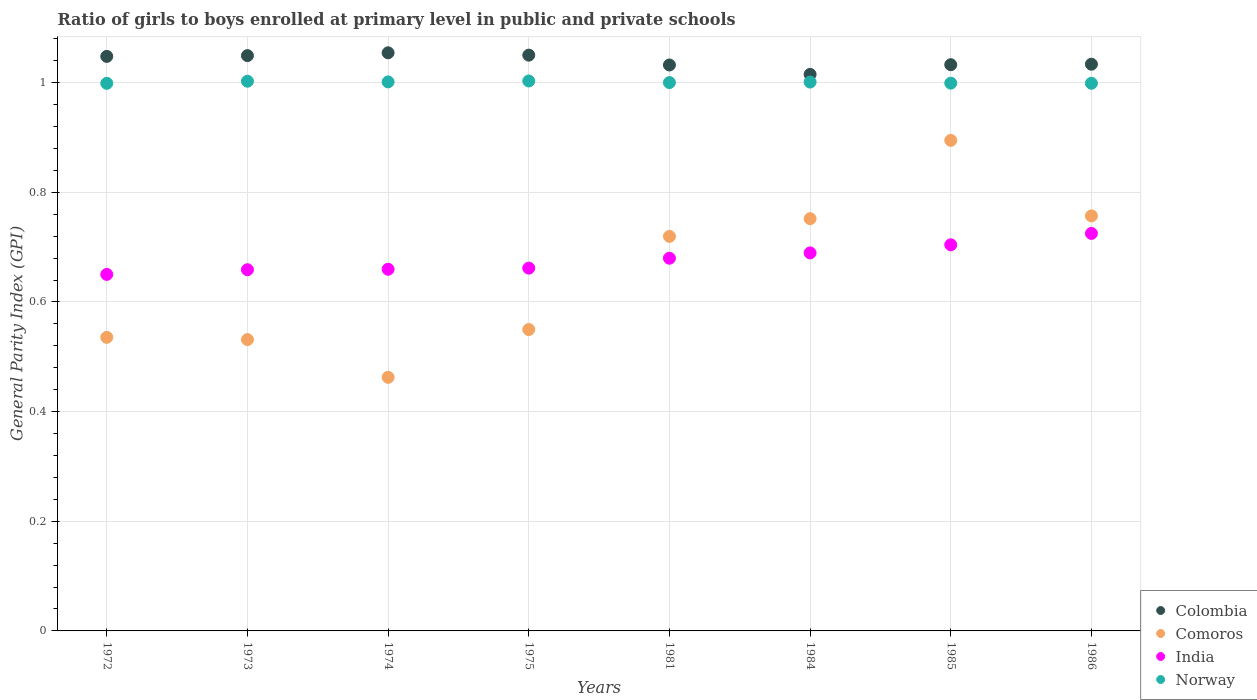How many different coloured dotlines are there?
Keep it short and to the point. 4. Is the number of dotlines equal to the number of legend labels?
Offer a very short reply. Yes. What is the general parity index in Comoros in 1975?
Your answer should be very brief. 0.55. Across all years, what is the maximum general parity index in Colombia?
Your answer should be very brief. 1.05. Across all years, what is the minimum general parity index in Colombia?
Offer a very short reply. 1.02. In which year was the general parity index in Norway maximum?
Keep it short and to the point. 1975. What is the total general parity index in Colombia in the graph?
Give a very brief answer. 8.32. What is the difference between the general parity index in Norway in 1973 and that in 1974?
Make the answer very short. 0. What is the difference between the general parity index in Norway in 1973 and the general parity index in India in 1974?
Offer a very short reply. 0.34. What is the average general parity index in India per year?
Keep it short and to the point. 0.68. In the year 1974, what is the difference between the general parity index in Colombia and general parity index in India?
Make the answer very short. 0.39. In how many years, is the general parity index in Colombia greater than 0.6400000000000001?
Make the answer very short. 8. What is the ratio of the general parity index in India in 1972 to that in 1973?
Give a very brief answer. 0.99. Is the general parity index in Colombia in 1974 less than that in 1984?
Keep it short and to the point. No. What is the difference between the highest and the second highest general parity index in Comoros?
Ensure brevity in your answer.  0.14. What is the difference between the highest and the lowest general parity index in India?
Give a very brief answer. 0.07. Is it the case that in every year, the sum of the general parity index in Comoros and general parity index in Norway  is greater than the sum of general parity index in India and general parity index in Colombia?
Make the answer very short. Yes. Is it the case that in every year, the sum of the general parity index in India and general parity index in Comoros  is greater than the general parity index in Colombia?
Your answer should be very brief. Yes. Is the general parity index in Norway strictly greater than the general parity index in Colombia over the years?
Keep it short and to the point. No. How many dotlines are there?
Your answer should be compact. 4. Does the graph contain any zero values?
Make the answer very short. No. Does the graph contain grids?
Offer a terse response. Yes. What is the title of the graph?
Offer a very short reply. Ratio of girls to boys enrolled at primary level in public and private schools. Does "Panama" appear as one of the legend labels in the graph?
Keep it short and to the point. No. What is the label or title of the X-axis?
Provide a succinct answer. Years. What is the label or title of the Y-axis?
Offer a terse response. General Parity Index (GPI). What is the General Parity Index (GPI) in Colombia in 1972?
Keep it short and to the point. 1.05. What is the General Parity Index (GPI) in Comoros in 1972?
Provide a short and direct response. 0.54. What is the General Parity Index (GPI) of India in 1972?
Your response must be concise. 0.65. What is the General Parity Index (GPI) of Norway in 1972?
Provide a short and direct response. 1. What is the General Parity Index (GPI) in Colombia in 1973?
Ensure brevity in your answer.  1.05. What is the General Parity Index (GPI) of Comoros in 1973?
Give a very brief answer. 0.53. What is the General Parity Index (GPI) in India in 1973?
Ensure brevity in your answer.  0.66. What is the General Parity Index (GPI) in Norway in 1973?
Offer a very short reply. 1. What is the General Parity Index (GPI) in Colombia in 1974?
Your answer should be compact. 1.05. What is the General Parity Index (GPI) of Comoros in 1974?
Your answer should be compact. 0.46. What is the General Parity Index (GPI) of India in 1974?
Offer a terse response. 0.66. What is the General Parity Index (GPI) of Norway in 1974?
Your answer should be compact. 1. What is the General Parity Index (GPI) of Colombia in 1975?
Ensure brevity in your answer.  1.05. What is the General Parity Index (GPI) in Comoros in 1975?
Your response must be concise. 0.55. What is the General Parity Index (GPI) in India in 1975?
Offer a very short reply. 0.66. What is the General Parity Index (GPI) in Norway in 1975?
Your answer should be very brief. 1. What is the General Parity Index (GPI) of Colombia in 1981?
Give a very brief answer. 1.03. What is the General Parity Index (GPI) in Comoros in 1981?
Provide a short and direct response. 0.72. What is the General Parity Index (GPI) of India in 1981?
Provide a short and direct response. 0.68. What is the General Parity Index (GPI) in Norway in 1981?
Offer a terse response. 1. What is the General Parity Index (GPI) in Colombia in 1984?
Your response must be concise. 1.02. What is the General Parity Index (GPI) of Comoros in 1984?
Your answer should be very brief. 0.75. What is the General Parity Index (GPI) of India in 1984?
Keep it short and to the point. 0.69. What is the General Parity Index (GPI) in Norway in 1984?
Your response must be concise. 1. What is the General Parity Index (GPI) of Colombia in 1985?
Keep it short and to the point. 1.03. What is the General Parity Index (GPI) of Comoros in 1985?
Keep it short and to the point. 0.89. What is the General Parity Index (GPI) in India in 1985?
Keep it short and to the point. 0.7. What is the General Parity Index (GPI) of Norway in 1985?
Your response must be concise. 1. What is the General Parity Index (GPI) of Colombia in 1986?
Your answer should be very brief. 1.03. What is the General Parity Index (GPI) in Comoros in 1986?
Your answer should be very brief. 0.76. What is the General Parity Index (GPI) of India in 1986?
Give a very brief answer. 0.73. What is the General Parity Index (GPI) in Norway in 1986?
Your answer should be compact. 1. Across all years, what is the maximum General Parity Index (GPI) of Colombia?
Make the answer very short. 1.05. Across all years, what is the maximum General Parity Index (GPI) of Comoros?
Give a very brief answer. 0.89. Across all years, what is the maximum General Parity Index (GPI) of India?
Keep it short and to the point. 0.73. Across all years, what is the maximum General Parity Index (GPI) in Norway?
Ensure brevity in your answer.  1. Across all years, what is the minimum General Parity Index (GPI) in Colombia?
Give a very brief answer. 1.02. Across all years, what is the minimum General Parity Index (GPI) in Comoros?
Offer a terse response. 0.46. Across all years, what is the minimum General Parity Index (GPI) in India?
Ensure brevity in your answer.  0.65. Across all years, what is the minimum General Parity Index (GPI) of Norway?
Provide a succinct answer. 1. What is the total General Parity Index (GPI) of Colombia in the graph?
Provide a succinct answer. 8.32. What is the total General Parity Index (GPI) of Comoros in the graph?
Give a very brief answer. 5.2. What is the total General Parity Index (GPI) of India in the graph?
Offer a very short reply. 5.43. What is the total General Parity Index (GPI) in Norway in the graph?
Ensure brevity in your answer.  8.01. What is the difference between the General Parity Index (GPI) in Colombia in 1972 and that in 1973?
Provide a succinct answer. -0. What is the difference between the General Parity Index (GPI) of Comoros in 1972 and that in 1973?
Ensure brevity in your answer.  0. What is the difference between the General Parity Index (GPI) of India in 1972 and that in 1973?
Your answer should be very brief. -0.01. What is the difference between the General Parity Index (GPI) in Norway in 1972 and that in 1973?
Your response must be concise. -0. What is the difference between the General Parity Index (GPI) of Colombia in 1972 and that in 1974?
Ensure brevity in your answer.  -0.01. What is the difference between the General Parity Index (GPI) of Comoros in 1972 and that in 1974?
Your answer should be compact. 0.07. What is the difference between the General Parity Index (GPI) in India in 1972 and that in 1974?
Your response must be concise. -0.01. What is the difference between the General Parity Index (GPI) in Norway in 1972 and that in 1974?
Your response must be concise. -0. What is the difference between the General Parity Index (GPI) of Colombia in 1972 and that in 1975?
Provide a short and direct response. -0. What is the difference between the General Parity Index (GPI) of Comoros in 1972 and that in 1975?
Make the answer very short. -0.01. What is the difference between the General Parity Index (GPI) in India in 1972 and that in 1975?
Ensure brevity in your answer.  -0.01. What is the difference between the General Parity Index (GPI) of Norway in 1972 and that in 1975?
Your response must be concise. -0. What is the difference between the General Parity Index (GPI) of Colombia in 1972 and that in 1981?
Provide a succinct answer. 0.02. What is the difference between the General Parity Index (GPI) in Comoros in 1972 and that in 1981?
Ensure brevity in your answer.  -0.18. What is the difference between the General Parity Index (GPI) of India in 1972 and that in 1981?
Provide a short and direct response. -0.03. What is the difference between the General Parity Index (GPI) in Norway in 1972 and that in 1981?
Provide a short and direct response. -0. What is the difference between the General Parity Index (GPI) of Colombia in 1972 and that in 1984?
Provide a short and direct response. 0.03. What is the difference between the General Parity Index (GPI) in Comoros in 1972 and that in 1984?
Give a very brief answer. -0.22. What is the difference between the General Parity Index (GPI) in India in 1972 and that in 1984?
Give a very brief answer. -0.04. What is the difference between the General Parity Index (GPI) of Norway in 1972 and that in 1984?
Provide a short and direct response. -0. What is the difference between the General Parity Index (GPI) in Colombia in 1972 and that in 1985?
Offer a very short reply. 0.02. What is the difference between the General Parity Index (GPI) in Comoros in 1972 and that in 1985?
Offer a very short reply. -0.36. What is the difference between the General Parity Index (GPI) in India in 1972 and that in 1985?
Make the answer very short. -0.05. What is the difference between the General Parity Index (GPI) in Norway in 1972 and that in 1985?
Give a very brief answer. -0. What is the difference between the General Parity Index (GPI) of Colombia in 1972 and that in 1986?
Your response must be concise. 0.01. What is the difference between the General Parity Index (GPI) in Comoros in 1972 and that in 1986?
Keep it short and to the point. -0.22. What is the difference between the General Parity Index (GPI) of India in 1972 and that in 1986?
Your answer should be very brief. -0.07. What is the difference between the General Parity Index (GPI) of Norway in 1972 and that in 1986?
Ensure brevity in your answer.  -0. What is the difference between the General Parity Index (GPI) of Colombia in 1973 and that in 1974?
Give a very brief answer. -0.01. What is the difference between the General Parity Index (GPI) of Comoros in 1973 and that in 1974?
Provide a short and direct response. 0.07. What is the difference between the General Parity Index (GPI) in India in 1973 and that in 1974?
Provide a short and direct response. -0. What is the difference between the General Parity Index (GPI) of Norway in 1973 and that in 1974?
Offer a very short reply. 0. What is the difference between the General Parity Index (GPI) of Colombia in 1973 and that in 1975?
Provide a succinct answer. -0. What is the difference between the General Parity Index (GPI) of Comoros in 1973 and that in 1975?
Ensure brevity in your answer.  -0.02. What is the difference between the General Parity Index (GPI) of India in 1973 and that in 1975?
Your answer should be very brief. -0. What is the difference between the General Parity Index (GPI) of Norway in 1973 and that in 1975?
Give a very brief answer. -0. What is the difference between the General Parity Index (GPI) of Colombia in 1973 and that in 1981?
Your response must be concise. 0.02. What is the difference between the General Parity Index (GPI) in Comoros in 1973 and that in 1981?
Provide a succinct answer. -0.19. What is the difference between the General Parity Index (GPI) of India in 1973 and that in 1981?
Provide a succinct answer. -0.02. What is the difference between the General Parity Index (GPI) of Norway in 1973 and that in 1981?
Provide a short and direct response. 0. What is the difference between the General Parity Index (GPI) of Colombia in 1973 and that in 1984?
Provide a short and direct response. 0.03. What is the difference between the General Parity Index (GPI) in Comoros in 1973 and that in 1984?
Offer a very short reply. -0.22. What is the difference between the General Parity Index (GPI) of India in 1973 and that in 1984?
Offer a terse response. -0.03. What is the difference between the General Parity Index (GPI) of Norway in 1973 and that in 1984?
Your answer should be very brief. 0. What is the difference between the General Parity Index (GPI) of Colombia in 1973 and that in 1985?
Provide a succinct answer. 0.02. What is the difference between the General Parity Index (GPI) of Comoros in 1973 and that in 1985?
Give a very brief answer. -0.36. What is the difference between the General Parity Index (GPI) of India in 1973 and that in 1985?
Offer a terse response. -0.05. What is the difference between the General Parity Index (GPI) in Norway in 1973 and that in 1985?
Make the answer very short. 0. What is the difference between the General Parity Index (GPI) in Colombia in 1973 and that in 1986?
Offer a terse response. 0.02. What is the difference between the General Parity Index (GPI) of Comoros in 1973 and that in 1986?
Provide a succinct answer. -0.23. What is the difference between the General Parity Index (GPI) of India in 1973 and that in 1986?
Make the answer very short. -0.07. What is the difference between the General Parity Index (GPI) in Norway in 1973 and that in 1986?
Ensure brevity in your answer.  0. What is the difference between the General Parity Index (GPI) in Colombia in 1974 and that in 1975?
Ensure brevity in your answer.  0. What is the difference between the General Parity Index (GPI) in Comoros in 1974 and that in 1975?
Provide a succinct answer. -0.09. What is the difference between the General Parity Index (GPI) in India in 1974 and that in 1975?
Offer a terse response. -0. What is the difference between the General Parity Index (GPI) of Norway in 1974 and that in 1975?
Offer a very short reply. -0. What is the difference between the General Parity Index (GPI) of Colombia in 1974 and that in 1981?
Your answer should be compact. 0.02. What is the difference between the General Parity Index (GPI) of Comoros in 1974 and that in 1981?
Offer a very short reply. -0.26. What is the difference between the General Parity Index (GPI) of India in 1974 and that in 1981?
Provide a short and direct response. -0.02. What is the difference between the General Parity Index (GPI) of Norway in 1974 and that in 1981?
Provide a succinct answer. 0. What is the difference between the General Parity Index (GPI) in Colombia in 1974 and that in 1984?
Keep it short and to the point. 0.04. What is the difference between the General Parity Index (GPI) in Comoros in 1974 and that in 1984?
Keep it short and to the point. -0.29. What is the difference between the General Parity Index (GPI) in India in 1974 and that in 1984?
Provide a short and direct response. -0.03. What is the difference between the General Parity Index (GPI) of Norway in 1974 and that in 1984?
Give a very brief answer. 0. What is the difference between the General Parity Index (GPI) in Colombia in 1974 and that in 1985?
Provide a short and direct response. 0.02. What is the difference between the General Parity Index (GPI) in Comoros in 1974 and that in 1985?
Provide a succinct answer. -0.43. What is the difference between the General Parity Index (GPI) of India in 1974 and that in 1985?
Ensure brevity in your answer.  -0.04. What is the difference between the General Parity Index (GPI) of Norway in 1974 and that in 1985?
Give a very brief answer. 0. What is the difference between the General Parity Index (GPI) of Colombia in 1974 and that in 1986?
Provide a short and direct response. 0.02. What is the difference between the General Parity Index (GPI) in Comoros in 1974 and that in 1986?
Offer a very short reply. -0.29. What is the difference between the General Parity Index (GPI) in India in 1974 and that in 1986?
Your response must be concise. -0.07. What is the difference between the General Parity Index (GPI) of Norway in 1974 and that in 1986?
Your answer should be compact. 0. What is the difference between the General Parity Index (GPI) of Colombia in 1975 and that in 1981?
Your response must be concise. 0.02. What is the difference between the General Parity Index (GPI) in Comoros in 1975 and that in 1981?
Your answer should be compact. -0.17. What is the difference between the General Parity Index (GPI) of India in 1975 and that in 1981?
Offer a terse response. -0.02. What is the difference between the General Parity Index (GPI) in Norway in 1975 and that in 1981?
Offer a very short reply. 0. What is the difference between the General Parity Index (GPI) of Colombia in 1975 and that in 1984?
Offer a terse response. 0.04. What is the difference between the General Parity Index (GPI) of Comoros in 1975 and that in 1984?
Make the answer very short. -0.2. What is the difference between the General Parity Index (GPI) in India in 1975 and that in 1984?
Ensure brevity in your answer.  -0.03. What is the difference between the General Parity Index (GPI) of Norway in 1975 and that in 1984?
Offer a terse response. 0. What is the difference between the General Parity Index (GPI) in Colombia in 1975 and that in 1985?
Provide a short and direct response. 0.02. What is the difference between the General Parity Index (GPI) in Comoros in 1975 and that in 1985?
Ensure brevity in your answer.  -0.34. What is the difference between the General Parity Index (GPI) of India in 1975 and that in 1985?
Keep it short and to the point. -0.04. What is the difference between the General Parity Index (GPI) of Norway in 1975 and that in 1985?
Provide a short and direct response. 0. What is the difference between the General Parity Index (GPI) in Colombia in 1975 and that in 1986?
Offer a very short reply. 0.02. What is the difference between the General Parity Index (GPI) of Comoros in 1975 and that in 1986?
Your answer should be very brief. -0.21. What is the difference between the General Parity Index (GPI) in India in 1975 and that in 1986?
Offer a terse response. -0.06. What is the difference between the General Parity Index (GPI) in Norway in 1975 and that in 1986?
Offer a very short reply. 0. What is the difference between the General Parity Index (GPI) in Colombia in 1981 and that in 1984?
Offer a terse response. 0.02. What is the difference between the General Parity Index (GPI) of Comoros in 1981 and that in 1984?
Provide a short and direct response. -0.03. What is the difference between the General Parity Index (GPI) in India in 1981 and that in 1984?
Give a very brief answer. -0.01. What is the difference between the General Parity Index (GPI) in Norway in 1981 and that in 1984?
Provide a short and direct response. -0. What is the difference between the General Parity Index (GPI) of Colombia in 1981 and that in 1985?
Keep it short and to the point. -0. What is the difference between the General Parity Index (GPI) in Comoros in 1981 and that in 1985?
Your response must be concise. -0.18. What is the difference between the General Parity Index (GPI) of India in 1981 and that in 1985?
Your answer should be compact. -0.02. What is the difference between the General Parity Index (GPI) of Norway in 1981 and that in 1985?
Give a very brief answer. 0. What is the difference between the General Parity Index (GPI) of Colombia in 1981 and that in 1986?
Your answer should be very brief. -0. What is the difference between the General Parity Index (GPI) in Comoros in 1981 and that in 1986?
Offer a terse response. -0.04. What is the difference between the General Parity Index (GPI) of India in 1981 and that in 1986?
Provide a succinct answer. -0.05. What is the difference between the General Parity Index (GPI) in Norway in 1981 and that in 1986?
Offer a very short reply. 0. What is the difference between the General Parity Index (GPI) in Colombia in 1984 and that in 1985?
Ensure brevity in your answer.  -0.02. What is the difference between the General Parity Index (GPI) in Comoros in 1984 and that in 1985?
Offer a very short reply. -0.14. What is the difference between the General Parity Index (GPI) of India in 1984 and that in 1985?
Your answer should be very brief. -0.01. What is the difference between the General Parity Index (GPI) of Norway in 1984 and that in 1985?
Provide a succinct answer. 0. What is the difference between the General Parity Index (GPI) in Colombia in 1984 and that in 1986?
Provide a succinct answer. -0.02. What is the difference between the General Parity Index (GPI) of Comoros in 1984 and that in 1986?
Provide a short and direct response. -0.01. What is the difference between the General Parity Index (GPI) of India in 1984 and that in 1986?
Your answer should be compact. -0.04. What is the difference between the General Parity Index (GPI) in Norway in 1984 and that in 1986?
Your response must be concise. 0. What is the difference between the General Parity Index (GPI) in Colombia in 1985 and that in 1986?
Your answer should be very brief. -0. What is the difference between the General Parity Index (GPI) in Comoros in 1985 and that in 1986?
Offer a very short reply. 0.14. What is the difference between the General Parity Index (GPI) in India in 1985 and that in 1986?
Your answer should be compact. -0.02. What is the difference between the General Parity Index (GPI) in Colombia in 1972 and the General Parity Index (GPI) in Comoros in 1973?
Provide a succinct answer. 0.52. What is the difference between the General Parity Index (GPI) in Colombia in 1972 and the General Parity Index (GPI) in India in 1973?
Keep it short and to the point. 0.39. What is the difference between the General Parity Index (GPI) in Colombia in 1972 and the General Parity Index (GPI) in Norway in 1973?
Keep it short and to the point. 0.05. What is the difference between the General Parity Index (GPI) in Comoros in 1972 and the General Parity Index (GPI) in India in 1973?
Give a very brief answer. -0.12. What is the difference between the General Parity Index (GPI) of Comoros in 1972 and the General Parity Index (GPI) of Norway in 1973?
Offer a very short reply. -0.47. What is the difference between the General Parity Index (GPI) of India in 1972 and the General Parity Index (GPI) of Norway in 1973?
Your answer should be compact. -0.35. What is the difference between the General Parity Index (GPI) of Colombia in 1972 and the General Parity Index (GPI) of Comoros in 1974?
Make the answer very short. 0.59. What is the difference between the General Parity Index (GPI) in Colombia in 1972 and the General Parity Index (GPI) in India in 1974?
Give a very brief answer. 0.39. What is the difference between the General Parity Index (GPI) in Colombia in 1972 and the General Parity Index (GPI) in Norway in 1974?
Provide a short and direct response. 0.05. What is the difference between the General Parity Index (GPI) of Comoros in 1972 and the General Parity Index (GPI) of India in 1974?
Give a very brief answer. -0.12. What is the difference between the General Parity Index (GPI) in Comoros in 1972 and the General Parity Index (GPI) in Norway in 1974?
Keep it short and to the point. -0.47. What is the difference between the General Parity Index (GPI) in India in 1972 and the General Parity Index (GPI) in Norway in 1974?
Provide a short and direct response. -0.35. What is the difference between the General Parity Index (GPI) of Colombia in 1972 and the General Parity Index (GPI) of Comoros in 1975?
Make the answer very short. 0.5. What is the difference between the General Parity Index (GPI) of Colombia in 1972 and the General Parity Index (GPI) of India in 1975?
Make the answer very short. 0.39. What is the difference between the General Parity Index (GPI) of Colombia in 1972 and the General Parity Index (GPI) of Norway in 1975?
Offer a very short reply. 0.04. What is the difference between the General Parity Index (GPI) in Comoros in 1972 and the General Parity Index (GPI) in India in 1975?
Offer a very short reply. -0.13. What is the difference between the General Parity Index (GPI) of Comoros in 1972 and the General Parity Index (GPI) of Norway in 1975?
Give a very brief answer. -0.47. What is the difference between the General Parity Index (GPI) of India in 1972 and the General Parity Index (GPI) of Norway in 1975?
Give a very brief answer. -0.35. What is the difference between the General Parity Index (GPI) in Colombia in 1972 and the General Parity Index (GPI) in Comoros in 1981?
Make the answer very short. 0.33. What is the difference between the General Parity Index (GPI) of Colombia in 1972 and the General Parity Index (GPI) of India in 1981?
Provide a succinct answer. 0.37. What is the difference between the General Parity Index (GPI) in Colombia in 1972 and the General Parity Index (GPI) in Norway in 1981?
Your answer should be compact. 0.05. What is the difference between the General Parity Index (GPI) of Comoros in 1972 and the General Parity Index (GPI) of India in 1981?
Your answer should be very brief. -0.14. What is the difference between the General Parity Index (GPI) of Comoros in 1972 and the General Parity Index (GPI) of Norway in 1981?
Ensure brevity in your answer.  -0.46. What is the difference between the General Parity Index (GPI) of India in 1972 and the General Parity Index (GPI) of Norway in 1981?
Offer a very short reply. -0.35. What is the difference between the General Parity Index (GPI) in Colombia in 1972 and the General Parity Index (GPI) in Comoros in 1984?
Your answer should be compact. 0.3. What is the difference between the General Parity Index (GPI) in Colombia in 1972 and the General Parity Index (GPI) in India in 1984?
Provide a short and direct response. 0.36. What is the difference between the General Parity Index (GPI) in Colombia in 1972 and the General Parity Index (GPI) in Norway in 1984?
Provide a short and direct response. 0.05. What is the difference between the General Parity Index (GPI) in Comoros in 1972 and the General Parity Index (GPI) in India in 1984?
Make the answer very short. -0.15. What is the difference between the General Parity Index (GPI) of Comoros in 1972 and the General Parity Index (GPI) of Norway in 1984?
Keep it short and to the point. -0.47. What is the difference between the General Parity Index (GPI) in India in 1972 and the General Parity Index (GPI) in Norway in 1984?
Your answer should be compact. -0.35. What is the difference between the General Parity Index (GPI) in Colombia in 1972 and the General Parity Index (GPI) in Comoros in 1985?
Provide a short and direct response. 0.15. What is the difference between the General Parity Index (GPI) of Colombia in 1972 and the General Parity Index (GPI) of India in 1985?
Your answer should be compact. 0.34. What is the difference between the General Parity Index (GPI) in Colombia in 1972 and the General Parity Index (GPI) in Norway in 1985?
Make the answer very short. 0.05. What is the difference between the General Parity Index (GPI) of Comoros in 1972 and the General Parity Index (GPI) of India in 1985?
Give a very brief answer. -0.17. What is the difference between the General Parity Index (GPI) of Comoros in 1972 and the General Parity Index (GPI) of Norway in 1985?
Provide a succinct answer. -0.46. What is the difference between the General Parity Index (GPI) of India in 1972 and the General Parity Index (GPI) of Norway in 1985?
Offer a terse response. -0.35. What is the difference between the General Parity Index (GPI) in Colombia in 1972 and the General Parity Index (GPI) in Comoros in 1986?
Give a very brief answer. 0.29. What is the difference between the General Parity Index (GPI) in Colombia in 1972 and the General Parity Index (GPI) in India in 1986?
Provide a succinct answer. 0.32. What is the difference between the General Parity Index (GPI) of Colombia in 1972 and the General Parity Index (GPI) of Norway in 1986?
Offer a very short reply. 0.05. What is the difference between the General Parity Index (GPI) of Comoros in 1972 and the General Parity Index (GPI) of India in 1986?
Your answer should be compact. -0.19. What is the difference between the General Parity Index (GPI) of Comoros in 1972 and the General Parity Index (GPI) of Norway in 1986?
Your response must be concise. -0.46. What is the difference between the General Parity Index (GPI) in India in 1972 and the General Parity Index (GPI) in Norway in 1986?
Your answer should be very brief. -0.35. What is the difference between the General Parity Index (GPI) in Colombia in 1973 and the General Parity Index (GPI) in Comoros in 1974?
Offer a terse response. 0.59. What is the difference between the General Parity Index (GPI) in Colombia in 1973 and the General Parity Index (GPI) in India in 1974?
Your answer should be very brief. 0.39. What is the difference between the General Parity Index (GPI) in Colombia in 1973 and the General Parity Index (GPI) in Norway in 1974?
Provide a succinct answer. 0.05. What is the difference between the General Parity Index (GPI) of Comoros in 1973 and the General Parity Index (GPI) of India in 1974?
Keep it short and to the point. -0.13. What is the difference between the General Parity Index (GPI) of Comoros in 1973 and the General Parity Index (GPI) of Norway in 1974?
Your answer should be compact. -0.47. What is the difference between the General Parity Index (GPI) in India in 1973 and the General Parity Index (GPI) in Norway in 1974?
Offer a terse response. -0.34. What is the difference between the General Parity Index (GPI) of Colombia in 1973 and the General Parity Index (GPI) of Comoros in 1975?
Ensure brevity in your answer.  0.5. What is the difference between the General Parity Index (GPI) of Colombia in 1973 and the General Parity Index (GPI) of India in 1975?
Your answer should be very brief. 0.39. What is the difference between the General Parity Index (GPI) in Colombia in 1973 and the General Parity Index (GPI) in Norway in 1975?
Make the answer very short. 0.05. What is the difference between the General Parity Index (GPI) in Comoros in 1973 and the General Parity Index (GPI) in India in 1975?
Give a very brief answer. -0.13. What is the difference between the General Parity Index (GPI) in Comoros in 1973 and the General Parity Index (GPI) in Norway in 1975?
Your response must be concise. -0.47. What is the difference between the General Parity Index (GPI) in India in 1973 and the General Parity Index (GPI) in Norway in 1975?
Your answer should be very brief. -0.34. What is the difference between the General Parity Index (GPI) of Colombia in 1973 and the General Parity Index (GPI) of Comoros in 1981?
Provide a short and direct response. 0.33. What is the difference between the General Parity Index (GPI) in Colombia in 1973 and the General Parity Index (GPI) in India in 1981?
Your answer should be very brief. 0.37. What is the difference between the General Parity Index (GPI) of Colombia in 1973 and the General Parity Index (GPI) of Norway in 1981?
Ensure brevity in your answer.  0.05. What is the difference between the General Parity Index (GPI) of Comoros in 1973 and the General Parity Index (GPI) of India in 1981?
Offer a very short reply. -0.15. What is the difference between the General Parity Index (GPI) of Comoros in 1973 and the General Parity Index (GPI) of Norway in 1981?
Your answer should be compact. -0.47. What is the difference between the General Parity Index (GPI) of India in 1973 and the General Parity Index (GPI) of Norway in 1981?
Ensure brevity in your answer.  -0.34. What is the difference between the General Parity Index (GPI) in Colombia in 1973 and the General Parity Index (GPI) in Comoros in 1984?
Your answer should be very brief. 0.3. What is the difference between the General Parity Index (GPI) in Colombia in 1973 and the General Parity Index (GPI) in India in 1984?
Provide a succinct answer. 0.36. What is the difference between the General Parity Index (GPI) in Colombia in 1973 and the General Parity Index (GPI) in Norway in 1984?
Offer a very short reply. 0.05. What is the difference between the General Parity Index (GPI) in Comoros in 1973 and the General Parity Index (GPI) in India in 1984?
Keep it short and to the point. -0.16. What is the difference between the General Parity Index (GPI) of Comoros in 1973 and the General Parity Index (GPI) of Norway in 1984?
Provide a succinct answer. -0.47. What is the difference between the General Parity Index (GPI) in India in 1973 and the General Parity Index (GPI) in Norway in 1984?
Offer a terse response. -0.34. What is the difference between the General Parity Index (GPI) in Colombia in 1973 and the General Parity Index (GPI) in Comoros in 1985?
Ensure brevity in your answer.  0.15. What is the difference between the General Parity Index (GPI) in Colombia in 1973 and the General Parity Index (GPI) in India in 1985?
Your answer should be compact. 0.35. What is the difference between the General Parity Index (GPI) in Colombia in 1973 and the General Parity Index (GPI) in Norway in 1985?
Provide a succinct answer. 0.05. What is the difference between the General Parity Index (GPI) in Comoros in 1973 and the General Parity Index (GPI) in India in 1985?
Offer a terse response. -0.17. What is the difference between the General Parity Index (GPI) in Comoros in 1973 and the General Parity Index (GPI) in Norway in 1985?
Your answer should be very brief. -0.47. What is the difference between the General Parity Index (GPI) in India in 1973 and the General Parity Index (GPI) in Norway in 1985?
Provide a short and direct response. -0.34. What is the difference between the General Parity Index (GPI) in Colombia in 1973 and the General Parity Index (GPI) in Comoros in 1986?
Your response must be concise. 0.29. What is the difference between the General Parity Index (GPI) in Colombia in 1973 and the General Parity Index (GPI) in India in 1986?
Offer a terse response. 0.32. What is the difference between the General Parity Index (GPI) in Colombia in 1973 and the General Parity Index (GPI) in Norway in 1986?
Offer a terse response. 0.05. What is the difference between the General Parity Index (GPI) of Comoros in 1973 and the General Parity Index (GPI) of India in 1986?
Provide a succinct answer. -0.19. What is the difference between the General Parity Index (GPI) in Comoros in 1973 and the General Parity Index (GPI) in Norway in 1986?
Your answer should be very brief. -0.47. What is the difference between the General Parity Index (GPI) in India in 1973 and the General Parity Index (GPI) in Norway in 1986?
Your answer should be compact. -0.34. What is the difference between the General Parity Index (GPI) of Colombia in 1974 and the General Parity Index (GPI) of Comoros in 1975?
Offer a very short reply. 0.5. What is the difference between the General Parity Index (GPI) of Colombia in 1974 and the General Parity Index (GPI) of India in 1975?
Give a very brief answer. 0.39. What is the difference between the General Parity Index (GPI) in Colombia in 1974 and the General Parity Index (GPI) in Norway in 1975?
Keep it short and to the point. 0.05. What is the difference between the General Parity Index (GPI) in Comoros in 1974 and the General Parity Index (GPI) in India in 1975?
Ensure brevity in your answer.  -0.2. What is the difference between the General Parity Index (GPI) of Comoros in 1974 and the General Parity Index (GPI) of Norway in 1975?
Provide a short and direct response. -0.54. What is the difference between the General Parity Index (GPI) of India in 1974 and the General Parity Index (GPI) of Norway in 1975?
Keep it short and to the point. -0.34. What is the difference between the General Parity Index (GPI) in Colombia in 1974 and the General Parity Index (GPI) in Comoros in 1981?
Offer a very short reply. 0.33. What is the difference between the General Parity Index (GPI) of Colombia in 1974 and the General Parity Index (GPI) of India in 1981?
Your answer should be very brief. 0.37. What is the difference between the General Parity Index (GPI) in Colombia in 1974 and the General Parity Index (GPI) in Norway in 1981?
Your response must be concise. 0.05. What is the difference between the General Parity Index (GPI) in Comoros in 1974 and the General Parity Index (GPI) in India in 1981?
Your response must be concise. -0.22. What is the difference between the General Parity Index (GPI) in Comoros in 1974 and the General Parity Index (GPI) in Norway in 1981?
Offer a terse response. -0.54. What is the difference between the General Parity Index (GPI) in India in 1974 and the General Parity Index (GPI) in Norway in 1981?
Offer a terse response. -0.34. What is the difference between the General Parity Index (GPI) of Colombia in 1974 and the General Parity Index (GPI) of Comoros in 1984?
Your answer should be very brief. 0.3. What is the difference between the General Parity Index (GPI) in Colombia in 1974 and the General Parity Index (GPI) in India in 1984?
Provide a succinct answer. 0.36. What is the difference between the General Parity Index (GPI) of Colombia in 1974 and the General Parity Index (GPI) of Norway in 1984?
Your answer should be compact. 0.05. What is the difference between the General Parity Index (GPI) of Comoros in 1974 and the General Parity Index (GPI) of India in 1984?
Ensure brevity in your answer.  -0.23. What is the difference between the General Parity Index (GPI) of Comoros in 1974 and the General Parity Index (GPI) of Norway in 1984?
Provide a short and direct response. -0.54. What is the difference between the General Parity Index (GPI) in India in 1974 and the General Parity Index (GPI) in Norway in 1984?
Offer a very short reply. -0.34. What is the difference between the General Parity Index (GPI) of Colombia in 1974 and the General Parity Index (GPI) of Comoros in 1985?
Your answer should be compact. 0.16. What is the difference between the General Parity Index (GPI) of Colombia in 1974 and the General Parity Index (GPI) of India in 1985?
Make the answer very short. 0.35. What is the difference between the General Parity Index (GPI) of Colombia in 1974 and the General Parity Index (GPI) of Norway in 1985?
Provide a short and direct response. 0.06. What is the difference between the General Parity Index (GPI) in Comoros in 1974 and the General Parity Index (GPI) in India in 1985?
Offer a terse response. -0.24. What is the difference between the General Parity Index (GPI) in Comoros in 1974 and the General Parity Index (GPI) in Norway in 1985?
Offer a very short reply. -0.54. What is the difference between the General Parity Index (GPI) in India in 1974 and the General Parity Index (GPI) in Norway in 1985?
Your answer should be compact. -0.34. What is the difference between the General Parity Index (GPI) of Colombia in 1974 and the General Parity Index (GPI) of Comoros in 1986?
Make the answer very short. 0.3. What is the difference between the General Parity Index (GPI) of Colombia in 1974 and the General Parity Index (GPI) of India in 1986?
Offer a terse response. 0.33. What is the difference between the General Parity Index (GPI) of Colombia in 1974 and the General Parity Index (GPI) of Norway in 1986?
Offer a terse response. 0.06. What is the difference between the General Parity Index (GPI) of Comoros in 1974 and the General Parity Index (GPI) of India in 1986?
Your answer should be very brief. -0.26. What is the difference between the General Parity Index (GPI) in Comoros in 1974 and the General Parity Index (GPI) in Norway in 1986?
Offer a terse response. -0.54. What is the difference between the General Parity Index (GPI) of India in 1974 and the General Parity Index (GPI) of Norway in 1986?
Make the answer very short. -0.34. What is the difference between the General Parity Index (GPI) of Colombia in 1975 and the General Parity Index (GPI) of Comoros in 1981?
Provide a succinct answer. 0.33. What is the difference between the General Parity Index (GPI) of Colombia in 1975 and the General Parity Index (GPI) of India in 1981?
Your answer should be compact. 0.37. What is the difference between the General Parity Index (GPI) of Colombia in 1975 and the General Parity Index (GPI) of Norway in 1981?
Make the answer very short. 0.05. What is the difference between the General Parity Index (GPI) of Comoros in 1975 and the General Parity Index (GPI) of India in 1981?
Make the answer very short. -0.13. What is the difference between the General Parity Index (GPI) in Comoros in 1975 and the General Parity Index (GPI) in Norway in 1981?
Make the answer very short. -0.45. What is the difference between the General Parity Index (GPI) of India in 1975 and the General Parity Index (GPI) of Norway in 1981?
Offer a very short reply. -0.34. What is the difference between the General Parity Index (GPI) in Colombia in 1975 and the General Parity Index (GPI) in Comoros in 1984?
Offer a terse response. 0.3. What is the difference between the General Parity Index (GPI) in Colombia in 1975 and the General Parity Index (GPI) in India in 1984?
Make the answer very short. 0.36. What is the difference between the General Parity Index (GPI) of Colombia in 1975 and the General Parity Index (GPI) of Norway in 1984?
Keep it short and to the point. 0.05. What is the difference between the General Parity Index (GPI) in Comoros in 1975 and the General Parity Index (GPI) in India in 1984?
Ensure brevity in your answer.  -0.14. What is the difference between the General Parity Index (GPI) of Comoros in 1975 and the General Parity Index (GPI) of Norway in 1984?
Your answer should be very brief. -0.45. What is the difference between the General Parity Index (GPI) in India in 1975 and the General Parity Index (GPI) in Norway in 1984?
Ensure brevity in your answer.  -0.34. What is the difference between the General Parity Index (GPI) of Colombia in 1975 and the General Parity Index (GPI) of Comoros in 1985?
Offer a terse response. 0.16. What is the difference between the General Parity Index (GPI) in Colombia in 1975 and the General Parity Index (GPI) in India in 1985?
Ensure brevity in your answer.  0.35. What is the difference between the General Parity Index (GPI) of Colombia in 1975 and the General Parity Index (GPI) of Norway in 1985?
Offer a terse response. 0.05. What is the difference between the General Parity Index (GPI) of Comoros in 1975 and the General Parity Index (GPI) of India in 1985?
Keep it short and to the point. -0.15. What is the difference between the General Parity Index (GPI) in Comoros in 1975 and the General Parity Index (GPI) in Norway in 1985?
Offer a terse response. -0.45. What is the difference between the General Parity Index (GPI) in India in 1975 and the General Parity Index (GPI) in Norway in 1985?
Provide a succinct answer. -0.34. What is the difference between the General Parity Index (GPI) of Colombia in 1975 and the General Parity Index (GPI) of Comoros in 1986?
Provide a succinct answer. 0.29. What is the difference between the General Parity Index (GPI) of Colombia in 1975 and the General Parity Index (GPI) of India in 1986?
Your answer should be compact. 0.33. What is the difference between the General Parity Index (GPI) of Colombia in 1975 and the General Parity Index (GPI) of Norway in 1986?
Your answer should be compact. 0.05. What is the difference between the General Parity Index (GPI) of Comoros in 1975 and the General Parity Index (GPI) of India in 1986?
Offer a terse response. -0.18. What is the difference between the General Parity Index (GPI) of Comoros in 1975 and the General Parity Index (GPI) of Norway in 1986?
Offer a terse response. -0.45. What is the difference between the General Parity Index (GPI) of India in 1975 and the General Parity Index (GPI) of Norway in 1986?
Offer a very short reply. -0.34. What is the difference between the General Parity Index (GPI) in Colombia in 1981 and the General Parity Index (GPI) in Comoros in 1984?
Offer a terse response. 0.28. What is the difference between the General Parity Index (GPI) in Colombia in 1981 and the General Parity Index (GPI) in India in 1984?
Your answer should be very brief. 0.34. What is the difference between the General Parity Index (GPI) of Colombia in 1981 and the General Parity Index (GPI) of Norway in 1984?
Provide a short and direct response. 0.03. What is the difference between the General Parity Index (GPI) in Comoros in 1981 and the General Parity Index (GPI) in India in 1984?
Ensure brevity in your answer.  0.03. What is the difference between the General Parity Index (GPI) of Comoros in 1981 and the General Parity Index (GPI) of Norway in 1984?
Your response must be concise. -0.28. What is the difference between the General Parity Index (GPI) of India in 1981 and the General Parity Index (GPI) of Norway in 1984?
Give a very brief answer. -0.32. What is the difference between the General Parity Index (GPI) in Colombia in 1981 and the General Parity Index (GPI) in Comoros in 1985?
Offer a terse response. 0.14. What is the difference between the General Parity Index (GPI) of Colombia in 1981 and the General Parity Index (GPI) of India in 1985?
Keep it short and to the point. 0.33. What is the difference between the General Parity Index (GPI) in Colombia in 1981 and the General Parity Index (GPI) in Norway in 1985?
Give a very brief answer. 0.03. What is the difference between the General Parity Index (GPI) of Comoros in 1981 and the General Parity Index (GPI) of India in 1985?
Provide a succinct answer. 0.02. What is the difference between the General Parity Index (GPI) in Comoros in 1981 and the General Parity Index (GPI) in Norway in 1985?
Your answer should be compact. -0.28. What is the difference between the General Parity Index (GPI) of India in 1981 and the General Parity Index (GPI) of Norway in 1985?
Your answer should be compact. -0.32. What is the difference between the General Parity Index (GPI) in Colombia in 1981 and the General Parity Index (GPI) in Comoros in 1986?
Provide a short and direct response. 0.28. What is the difference between the General Parity Index (GPI) of Colombia in 1981 and the General Parity Index (GPI) of India in 1986?
Your response must be concise. 0.31. What is the difference between the General Parity Index (GPI) of Colombia in 1981 and the General Parity Index (GPI) of Norway in 1986?
Your answer should be very brief. 0.03. What is the difference between the General Parity Index (GPI) of Comoros in 1981 and the General Parity Index (GPI) of India in 1986?
Offer a terse response. -0.01. What is the difference between the General Parity Index (GPI) in Comoros in 1981 and the General Parity Index (GPI) in Norway in 1986?
Offer a terse response. -0.28. What is the difference between the General Parity Index (GPI) in India in 1981 and the General Parity Index (GPI) in Norway in 1986?
Offer a terse response. -0.32. What is the difference between the General Parity Index (GPI) of Colombia in 1984 and the General Parity Index (GPI) of Comoros in 1985?
Your response must be concise. 0.12. What is the difference between the General Parity Index (GPI) of Colombia in 1984 and the General Parity Index (GPI) of India in 1985?
Offer a terse response. 0.31. What is the difference between the General Parity Index (GPI) in Colombia in 1984 and the General Parity Index (GPI) in Norway in 1985?
Make the answer very short. 0.02. What is the difference between the General Parity Index (GPI) of Comoros in 1984 and the General Parity Index (GPI) of India in 1985?
Offer a very short reply. 0.05. What is the difference between the General Parity Index (GPI) in Comoros in 1984 and the General Parity Index (GPI) in Norway in 1985?
Offer a terse response. -0.25. What is the difference between the General Parity Index (GPI) in India in 1984 and the General Parity Index (GPI) in Norway in 1985?
Your answer should be compact. -0.31. What is the difference between the General Parity Index (GPI) of Colombia in 1984 and the General Parity Index (GPI) of Comoros in 1986?
Your answer should be very brief. 0.26. What is the difference between the General Parity Index (GPI) of Colombia in 1984 and the General Parity Index (GPI) of India in 1986?
Make the answer very short. 0.29. What is the difference between the General Parity Index (GPI) of Colombia in 1984 and the General Parity Index (GPI) of Norway in 1986?
Make the answer very short. 0.02. What is the difference between the General Parity Index (GPI) of Comoros in 1984 and the General Parity Index (GPI) of India in 1986?
Keep it short and to the point. 0.03. What is the difference between the General Parity Index (GPI) in Comoros in 1984 and the General Parity Index (GPI) in Norway in 1986?
Make the answer very short. -0.25. What is the difference between the General Parity Index (GPI) of India in 1984 and the General Parity Index (GPI) of Norway in 1986?
Your answer should be compact. -0.31. What is the difference between the General Parity Index (GPI) in Colombia in 1985 and the General Parity Index (GPI) in Comoros in 1986?
Offer a terse response. 0.28. What is the difference between the General Parity Index (GPI) of Colombia in 1985 and the General Parity Index (GPI) of India in 1986?
Give a very brief answer. 0.31. What is the difference between the General Parity Index (GPI) in Colombia in 1985 and the General Parity Index (GPI) in Norway in 1986?
Offer a terse response. 0.03. What is the difference between the General Parity Index (GPI) of Comoros in 1985 and the General Parity Index (GPI) of India in 1986?
Make the answer very short. 0.17. What is the difference between the General Parity Index (GPI) in Comoros in 1985 and the General Parity Index (GPI) in Norway in 1986?
Offer a terse response. -0.1. What is the difference between the General Parity Index (GPI) of India in 1985 and the General Parity Index (GPI) of Norway in 1986?
Offer a terse response. -0.29. What is the average General Parity Index (GPI) of Colombia per year?
Provide a short and direct response. 1.04. What is the average General Parity Index (GPI) in Comoros per year?
Keep it short and to the point. 0.65. What is the average General Parity Index (GPI) of India per year?
Provide a succinct answer. 0.68. What is the average General Parity Index (GPI) of Norway per year?
Give a very brief answer. 1. In the year 1972, what is the difference between the General Parity Index (GPI) in Colombia and General Parity Index (GPI) in Comoros?
Make the answer very short. 0.51. In the year 1972, what is the difference between the General Parity Index (GPI) of Colombia and General Parity Index (GPI) of India?
Provide a succinct answer. 0.4. In the year 1972, what is the difference between the General Parity Index (GPI) of Colombia and General Parity Index (GPI) of Norway?
Provide a succinct answer. 0.05. In the year 1972, what is the difference between the General Parity Index (GPI) of Comoros and General Parity Index (GPI) of India?
Give a very brief answer. -0.11. In the year 1972, what is the difference between the General Parity Index (GPI) of Comoros and General Parity Index (GPI) of Norway?
Your answer should be compact. -0.46. In the year 1972, what is the difference between the General Parity Index (GPI) of India and General Parity Index (GPI) of Norway?
Offer a terse response. -0.35. In the year 1973, what is the difference between the General Parity Index (GPI) in Colombia and General Parity Index (GPI) in Comoros?
Offer a terse response. 0.52. In the year 1973, what is the difference between the General Parity Index (GPI) in Colombia and General Parity Index (GPI) in India?
Offer a very short reply. 0.39. In the year 1973, what is the difference between the General Parity Index (GPI) in Colombia and General Parity Index (GPI) in Norway?
Ensure brevity in your answer.  0.05. In the year 1973, what is the difference between the General Parity Index (GPI) in Comoros and General Parity Index (GPI) in India?
Provide a succinct answer. -0.13. In the year 1973, what is the difference between the General Parity Index (GPI) of Comoros and General Parity Index (GPI) of Norway?
Ensure brevity in your answer.  -0.47. In the year 1973, what is the difference between the General Parity Index (GPI) of India and General Parity Index (GPI) of Norway?
Provide a succinct answer. -0.34. In the year 1974, what is the difference between the General Parity Index (GPI) of Colombia and General Parity Index (GPI) of Comoros?
Ensure brevity in your answer.  0.59. In the year 1974, what is the difference between the General Parity Index (GPI) in Colombia and General Parity Index (GPI) in India?
Keep it short and to the point. 0.39. In the year 1974, what is the difference between the General Parity Index (GPI) in Colombia and General Parity Index (GPI) in Norway?
Make the answer very short. 0.05. In the year 1974, what is the difference between the General Parity Index (GPI) of Comoros and General Parity Index (GPI) of India?
Your response must be concise. -0.2. In the year 1974, what is the difference between the General Parity Index (GPI) in Comoros and General Parity Index (GPI) in Norway?
Provide a short and direct response. -0.54. In the year 1974, what is the difference between the General Parity Index (GPI) in India and General Parity Index (GPI) in Norway?
Keep it short and to the point. -0.34. In the year 1975, what is the difference between the General Parity Index (GPI) in Colombia and General Parity Index (GPI) in Comoros?
Provide a succinct answer. 0.5. In the year 1975, what is the difference between the General Parity Index (GPI) in Colombia and General Parity Index (GPI) in India?
Ensure brevity in your answer.  0.39. In the year 1975, what is the difference between the General Parity Index (GPI) of Colombia and General Parity Index (GPI) of Norway?
Your answer should be compact. 0.05. In the year 1975, what is the difference between the General Parity Index (GPI) in Comoros and General Parity Index (GPI) in India?
Your answer should be compact. -0.11. In the year 1975, what is the difference between the General Parity Index (GPI) in Comoros and General Parity Index (GPI) in Norway?
Your answer should be compact. -0.45. In the year 1975, what is the difference between the General Parity Index (GPI) in India and General Parity Index (GPI) in Norway?
Your response must be concise. -0.34. In the year 1981, what is the difference between the General Parity Index (GPI) in Colombia and General Parity Index (GPI) in Comoros?
Your response must be concise. 0.31. In the year 1981, what is the difference between the General Parity Index (GPI) of Colombia and General Parity Index (GPI) of India?
Give a very brief answer. 0.35. In the year 1981, what is the difference between the General Parity Index (GPI) in Colombia and General Parity Index (GPI) in Norway?
Ensure brevity in your answer.  0.03. In the year 1981, what is the difference between the General Parity Index (GPI) in Comoros and General Parity Index (GPI) in India?
Your response must be concise. 0.04. In the year 1981, what is the difference between the General Parity Index (GPI) of Comoros and General Parity Index (GPI) of Norway?
Offer a very short reply. -0.28. In the year 1981, what is the difference between the General Parity Index (GPI) of India and General Parity Index (GPI) of Norway?
Keep it short and to the point. -0.32. In the year 1984, what is the difference between the General Parity Index (GPI) of Colombia and General Parity Index (GPI) of Comoros?
Offer a very short reply. 0.26. In the year 1984, what is the difference between the General Parity Index (GPI) of Colombia and General Parity Index (GPI) of India?
Your answer should be very brief. 0.33. In the year 1984, what is the difference between the General Parity Index (GPI) of Colombia and General Parity Index (GPI) of Norway?
Keep it short and to the point. 0.01. In the year 1984, what is the difference between the General Parity Index (GPI) in Comoros and General Parity Index (GPI) in India?
Ensure brevity in your answer.  0.06. In the year 1984, what is the difference between the General Parity Index (GPI) of Comoros and General Parity Index (GPI) of Norway?
Give a very brief answer. -0.25. In the year 1984, what is the difference between the General Parity Index (GPI) in India and General Parity Index (GPI) in Norway?
Provide a succinct answer. -0.31. In the year 1985, what is the difference between the General Parity Index (GPI) of Colombia and General Parity Index (GPI) of Comoros?
Offer a terse response. 0.14. In the year 1985, what is the difference between the General Parity Index (GPI) in Colombia and General Parity Index (GPI) in India?
Give a very brief answer. 0.33. In the year 1985, what is the difference between the General Parity Index (GPI) in Colombia and General Parity Index (GPI) in Norway?
Your answer should be compact. 0.03. In the year 1985, what is the difference between the General Parity Index (GPI) of Comoros and General Parity Index (GPI) of India?
Your response must be concise. 0.19. In the year 1985, what is the difference between the General Parity Index (GPI) of Comoros and General Parity Index (GPI) of Norway?
Offer a terse response. -0.1. In the year 1985, what is the difference between the General Parity Index (GPI) of India and General Parity Index (GPI) of Norway?
Your response must be concise. -0.29. In the year 1986, what is the difference between the General Parity Index (GPI) in Colombia and General Parity Index (GPI) in Comoros?
Your answer should be compact. 0.28. In the year 1986, what is the difference between the General Parity Index (GPI) in Colombia and General Parity Index (GPI) in India?
Provide a short and direct response. 0.31. In the year 1986, what is the difference between the General Parity Index (GPI) of Colombia and General Parity Index (GPI) of Norway?
Make the answer very short. 0.03. In the year 1986, what is the difference between the General Parity Index (GPI) in Comoros and General Parity Index (GPI) in India?
Provide a short and direct response. 0.03. In the year 1986, what is the difference between the General Parity Index (GPI) in Comoros and General Parity Index (GPI) in Norway?
Your answer should be compact. -0.24. In the year 1986, what is the difference between the General Parity Index (GPI) in India and General Parity Index (GPI) in Norway?
Offer a terse response. -0.27. What is the ratio of the General Parity Index (GPI) of Comoros in 1972 to that in 1973?
Keep it short and to the point. 1.01. What is the ratio of the General Parity Index (GPI) in India in 1972 to that in 1973?
Provide a succinct answer. 0.99. What is the ratio of the General Parity Index (GPI) in Comoros in 1972 to that in 1974?
Ensure brevity in your answer.  1.16. What is the ratio of the General Parity Index (GPI) of India in 1972 to that in 1974?
Your answer should be very brief. 0.99. What is the ratio of the General Parity Index (GPI) of Norway in 1972 to that in 1974?
Your answer should be compact. 1. What is the ratio of the General Parity Index (GPI) of Colombia in 1972 to that in 1975?
Provide a succinct answer. 1. What is the ratio of the General Parity Index (GPI) of India in 1972 to that in 1975?
Give a very brief answer. 0.98. What is the ratio of the General Parity Index (GPI) in Norway in 1972 to that in 1975?
Offer a terse response. 1. What is the ratio of the General Parity Index (GPI) of Colombia in 1972 to that in 1981?
Give a very brief answer. 1.02. What is the ratio of the General Parity Index (GPI) in Comoros in 1972 to that in 1981?
Your answer should be very brief. 0.74. What is the ratio of the General Parity Index (GPI) in India in 1972 to that in 1981?
Ensure brevity in your answer.  0.96. What is the ratio of the General Parity Index (GPI) in Norway in 1972 to that in 1981?
Offer a terse response. 1. What is the ratio of the General Parity Index (GPI) in Colombia in 1972 to that in 1984?
Ensure brevity in your answer.  1.03. What is the ratio of the General Parity Index (GPI) of Comoros in 1972 to that in 1984?
Make the answer very short. 0.71. What is the ratio of the General Parity Index (GPI) of India in 1972 to that in 1984?
Offer a very short reply. 0.94. What is the ratio of the General Parity Index (GPI) of Norway in 1972 to that in 1984?
Your response must be concise. 1. What is the ratio of the General Parity Index (GPI) in Colombia in 1972 to that in 1985?
Provide a short and direct response. 1.01. What is the ratio of the General Parity Index (GPI) of Comoros in 1972 to that in 1985?
Your response must be concise. 0.6. What is the ratio of the General Parity Index (GPI) of India in 1972 to that in 1985?
Offer a terse response. 0.92. What is the ratio of the General Parity Index (GPI) in Colombia in 1972 to that in 1986?
Ensure brevity in your answer.  1.01. What is the ratio of the General Parity Index (GPI) of Comoros in 1972 to that in 1986?
Your response must be concise. 0.71. What is the ratio of the General Parity Index (GPI) of India in 1972 to that in 1986?
Your answer should be very brief. 0.9. What is the ratio of the General Parity Index (GPI) of Norway in 1972 to that in 1986?
Make the answer very short. 1. What is the ratio of the General Parity Index (GPI) in Colombia in 1973 to that in 1974?
Ensure brevity in your answer.  1. What is the ratio of the General Parity Index (GPI) of Comoros in 1973 to that in 1974?
Your response must be concise. 1.15. What is the ratio of the General Parity Index (GPI) of Norway in 1973 to that in 1974?
Ensure brevity in your answer.  1. What is the ratio of the General Parity Index (GPI) of Colombia in 1973 to that in 1975?
Offer a terse response. 1. What is the ratio of the General Parity Index (GPI) in Comoros in 1973 to that in 1975?
Ensure brevity in your answer.  0.97. What is the ratio of the General Parity Index (GPI) in Colombia in 1973 to that in 1981?
Offer a terse response. 1.02. What is the ratio of the General Parity Index (GPI) of Comoros in 1973 to that in 1981?
Give a very brief answer. 0.74. What is the ratio of the General Parity Index (GPI) in India in 1973 to that in 1981?
Provide a short and direct response. 0.97. What is the ratio of the General Parity Index (GPI) in Norway in 1973 to that in 1981?
Your response must be concise. 1. What is the ratio of the General Parity Index (GPI) of Colombia in 1973 to that in 1984?
Give a very brief answer. 1.03. What is the ratio of the General Parity Index (GPI) in Comoros in 1973 to that in 1984?
Offer a terse response. 0.71. What is the ratio of the General Parity Index (GPI) in India in 1973 to that in 1984?
Your response must be concise. 0.96. What is the ratio of the General Parity Index (GPI) of Colombia in 1973 to that in 1985?
Ensure brevity in your answer.  1.02. What is the ratio of the General Parity Index (GPI) in Comoros in 1973 to that in 1985?
Your answer should be compact. 0.59. What is the ratio of the General Parity Index (GPI) of India in 1973 to that in 1985?
Your answer should be compact. 0.94. What is the ratio of the General Parity Index (GPI) in Colombia in 1973 to that in 1986?
Your answer should be compact. 1.02. What is the ratio of the General Parity Index (GPI) in Comoros in 1973 to that in 1986?
Offer a terse response. 0.7. What is the ratio of the General Parity Index (GPI) in India in 1973 to that in 1986?
Offer a very short reply. 0.91. What is the ratio of the General Parity Index (GPI) in Norway in 1973 to that in 1986?
Offer a very short reply. 1. What is the ratio of the General Parity Index (GPI) of Comoros in 1974 to that in 1975?
Your answer should be very brief. 0.84. What is the ratio of the General Parity Index (GPI) in Norway in 1974 to that in 1975?
Provide a short and direct response. 1. What is the ratio of the General Parity Index (GPI) of Colombia in 1974 to that in 1981?
Make the answer very short. 1.02. What is the ratio of the General Parity Index (GPI) in Comoros in 1974 to that in 1981?
Your answer should be compact. 0.64. What is the ratio of the General Parity Index (GPI) in India in 1974 to that in 1981?
Give a very brief answer. 0.97. What is the ratio of the General Parity Index (GPI) of Norway in 1974 to that in 1981?
Your answer should be compact. 1. What is the ratio of the General Parity Index (GPI) of Colombia in 1974 to that in 1984?
Make the answer very short. 1.04. What is the ratio of the General Parity Index (GPI) of Comoros in 1974 to that in 1984?
Offer a very short reply. 0.62. What is the ratio of the General Parity Index (GPI) of India in 1974 to that in 1984?
Offer a very short reply. 0.96. What is the ratio of the General Parity Index (GPI) in Norway in 1974 to that in 1984?
Make the answer very short. 1. What is the ratio of the General Parity Index (GPI) of Comoros in 1974 to that in 1985?
Keep it short and to the point. 0.52. What is the ratio of the General Parity Index (GPI) in India in 1974 to that in 1985?
Provide a short and direct response. 0.94. What is the ratio of the General Parity Index (GPI) of Norway in 1974 to that in 1985?
Give a very brief answer. 1. What is the ratio of the General Parity Index (GPI) in Colombia in 1974 to that in 1986?
Offer a very short reply. 1.02. What is the ratio of the General Parity Index (GPI) in Comoros in 1974 to that in 1986?
Provide a succinct answer. 0.61. What is the ratio of the General Parity Index (GPI) in India in 1974 to that in 1986?
Offer a terse response. 0.91. What is the ratio of the General Parity Index (GPI) of Colombia in 1975 to that in 1981?
Your response must be concise. 1.02. What is the ratio of the General Parity Index (GPI) of Comoros in 1975 to that in 1981?
Ensure brevity in your answer.  0.76. What is the ratio of the General Parity Index (GPI) in India in 1975 to that in 1981?
Your answer should be compact. 0.97. What is the ratio of the General Parity Index (GPI) in Norway in 1975 to that in 1981?
Keep it short and to the point. 1. What is the ratio of the General Parity Index (GPI) in Colombia in 1975 to that in 1984?
Make the answer very short. 1.03. What is the ratio of the General Parity Index (GPI) of Comoros in 1975 to that in 1984?
Ensure brevity in your answer.  0.73. What is the ratio of the General Parity Index (GPI) in India in 1975 to that in 1984?
Make the answer very short. 0.96. What is the ratio of the General Parity Index (GPI) of Colombia in 1975 to that in 1985?
Make the answer very short. 1.02. What is the ratio of the General Parity Index (GPI) of Comoros in 1975 to that in 1985?
Keep it short and to the point. 0.61. What is the ratio of the General Parity Index (GPI) of India in 1975 to that in 1985?
Provide a short and direct response. 0.94. What is the ratio of the General Parity Index (GPI) of Colombia in 1975 to that in 1986?
Provide a short and direct response. 1.02. What is the ratio of the General Parity Index (GPI) of Comoros in 1975 to that in 1986?
Provide a succinct answer. 0.73. What is the ratio of the General Parity Index (GPI) in India in 1975 to that in 1986?
Give a very brief answer. 0.91. What is the ratio of the General Parity Index (GPI) in Colombia in 1981 to that in 1984?
Provide a succinct answer. 1.02. What is the ratio of the General Parity Index (GPI) in Comoros in 1981 to that in 1984?
Keep it short and to the point. 0.96. What is the ratio of the General Parity Index (GPI) in India in 1981 to that in 1984?
Offer a very short reply. 0.99. What is the ratio of the General Parity Index (GPI) of Colombia in 1981 to that in 1985?
Make the answer very short. 1. What is the ratio of the General Parity Index (GPI) in Comoros in 1981 to that in 1985?
Keep it short and to the point. 0.8. What is the ratio of the General Parity Index (GPI) in India in 1981 to that in 1985?
Your answer should be very brief. 0.97. What is the ratio of the General Parity Index (GPI) in Comoros in 1981 to that in 1986?
Ensure brevity in your answer.  0.95. What is the ratio of the General Parity Index (GPI) in India in 1981 to that in 1986?
Your answer should be compact. 0.94. What is the ratio of the General Parity Index (GPI) in Colombia in 1984 to that in 1985?
Your answer should be compact. 0.98. What is the ratio of the General Parity Index (GPI) in Comoros in 1984 to that in 1985?
Make the answer very short. 0.84. What is the ratio of the General Parity Index (GPI) in Norway in 1984 to that in 1985?
Offer a terse response. 1. What is the ratio of the General Parity Index (GPI) in Comoros in 1984 to that in 1986?
Offer a terse response. 0.99. What is the ratio of the General Parity Index (GPI) of India in 1984 to that in 1986?
Offer a very short reply. 0.95. What is the ratio of the General Parity Index (GPI) in Norway in 1984 to that in 1986?
Provide a short and direct response. 1. What is the ratio of the General Parity Index (GPI) in Comoros in 1985 to that in 1986?
Ensure brevity in your answer.  1.18. What is the ratio of the General Parity Index (GPI) of India in 1985 to that in 1986?
Ensure brevity in your answer.  0.97. What is the difference between the highest and the second highest General Parity Index (GPI) of Colombia?
Offer a terse response. 0. What is the difference between the highest and the second highest General Parity Index (GPI) of Comoros?
Ensure brevity in your answer.  0.14. What is the difference between the highest and the second highest General Parity Index (GPI) in India?
Ensure brevity in your answer.  0.02. What is the difference between the highest and the lowest General Parity Index (GPI) of Colombia?
Keep it short and to the point. 0.04. What is the difference between the highest and the lowest General Parity Index (GPI) in Comoros?
Your response must be concise. 0.43. What is the difference between the highest and the lowest General Parity Index (GPI) of India?
Offer a very short reply. 0.07. What is the difference between the highest and the lowest General Parity Index (GPI) of Norway?
Offer a very short reply. 0. 